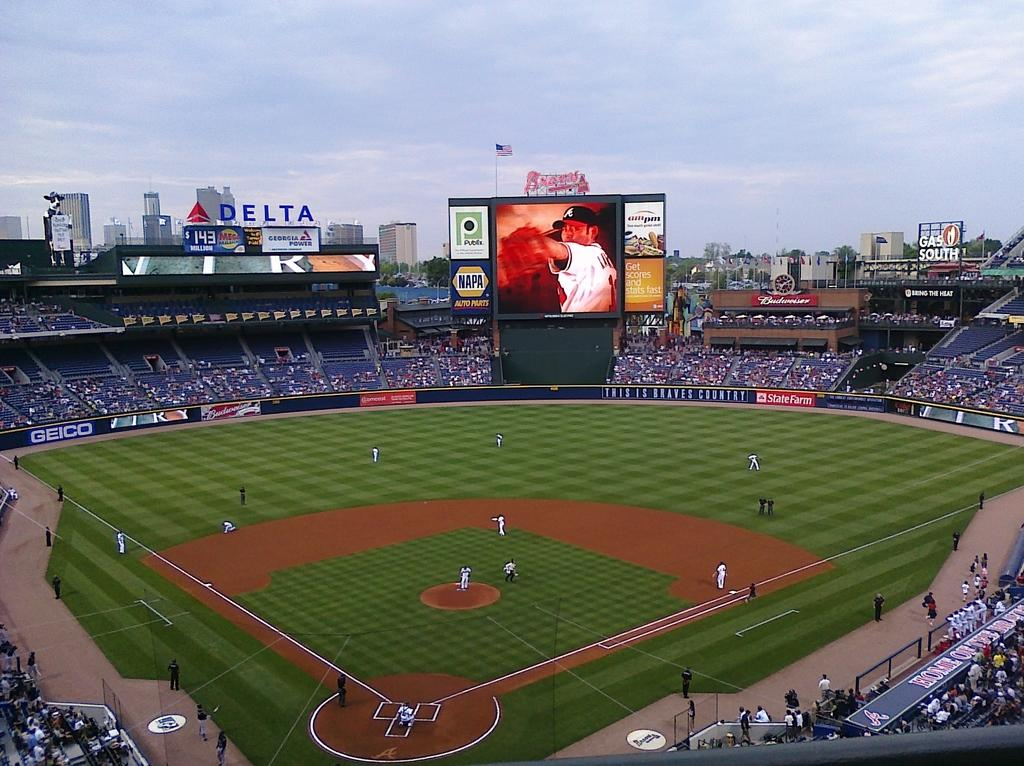<image>
Summarize the visual content of the image. The big ad sitting on top of the stadium is for Delta Airlines 